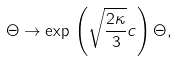<formula> <loc_0><loc_0><loc_500><loc_500>\Theta \to \exp \, \left ( \sqrt { \frac { 2 \kappa } { 3 } } c \right ) \Theta ,</formula> 